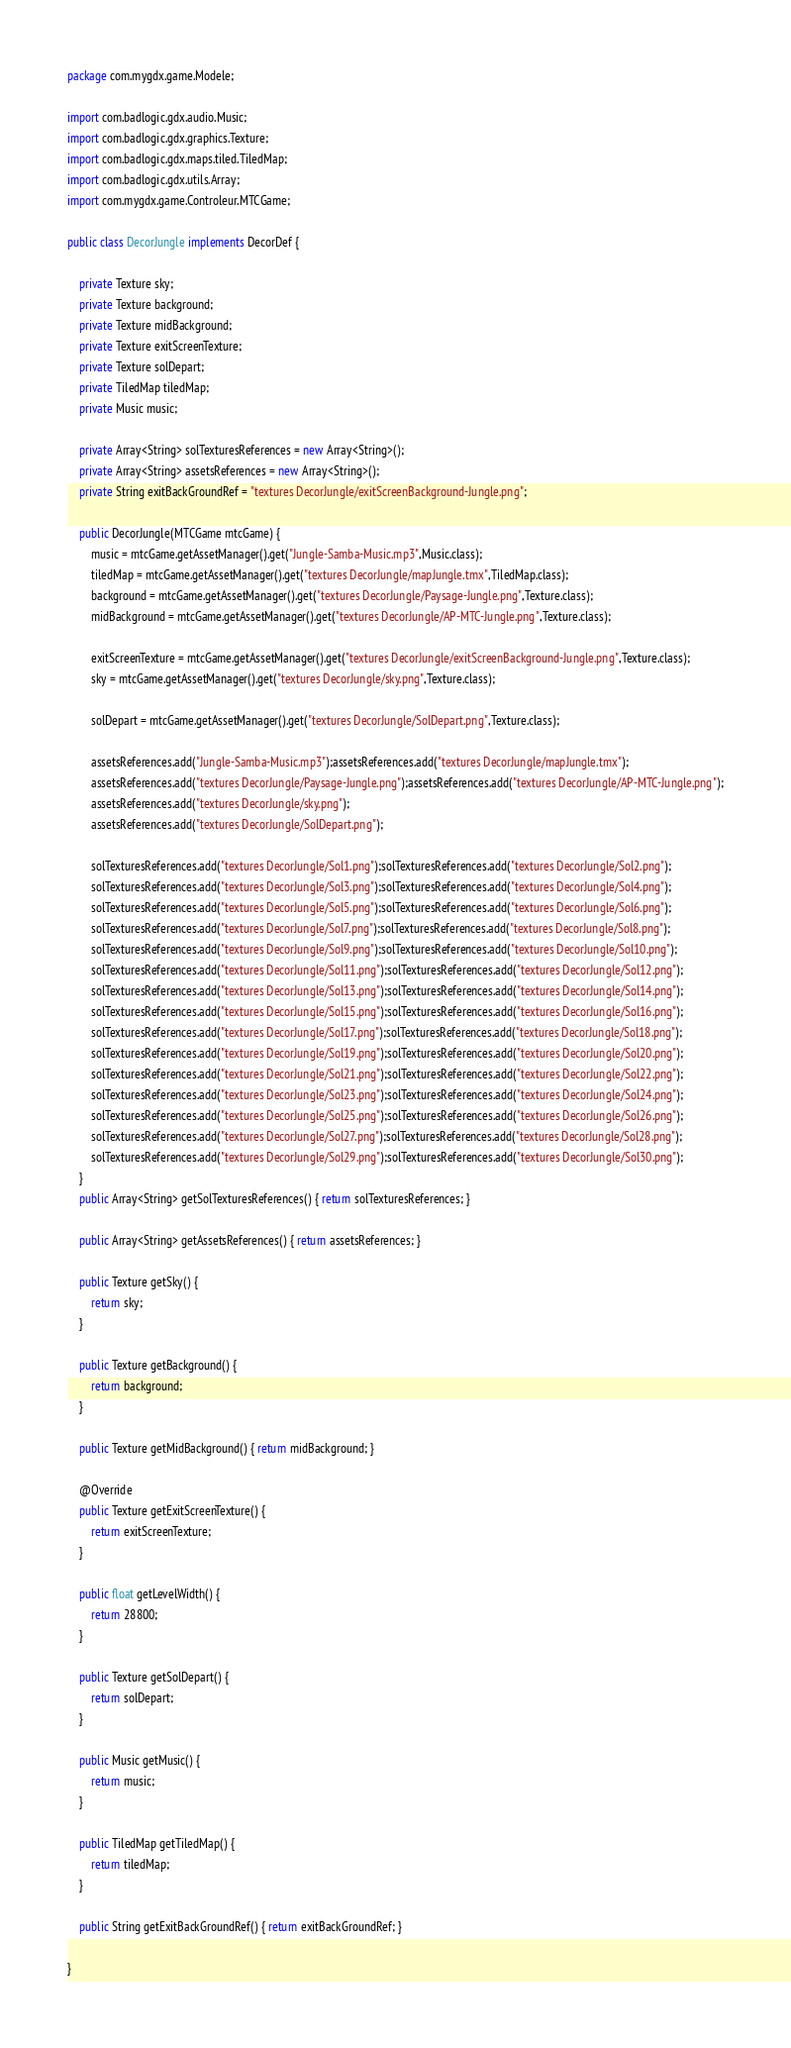Convert code to text. <code><loc_0><loc_0><loc_500><loc_500><_Java_>package com.mygdx.game.Modele;

import com.badlogic.gdx.audio.Music;
import com.badlogic.gdx.graphics.Texture;
import com.badlogic.gdx.maps.tiled.TiledMap;
import com.badlogic.gdx.utils.Array;
import com.mygdx.game.Controleur.MTCGame;

public class DecorJungle implements DecorDef {

    private Texture sky;
    private Texture background;
    private Texture midBackground;
    private Texture exitScreenTexture;
    private Texture solDepart;
    private TiledMap tiledMap;
    private Music music;

    private Array<String> solTexturesReferences = new Array<String>();
    private Array<String> assetsReferences = new Array<String>();
    private String exitBackGroundRef = "textures DecorJungle/exitScreenBackground-Jungle.png";

    public DecorJungle(MTCGame mtcGame) {
        music = mtcGame.getAssetManager().get("Jungle-Samba-Music.mp3",Music.class);
        tiledMap = mtcGame.getAssetManager().get("textures DecorJungle/mapJungle.tmx",TiledMap.class);
        background = mtcGame.getAssetManager().get("textures DecorJungle/Paysage-Jungle.png",Texture.class);
        midBackground = mtcGame.getAssetManager().get("textures DecorJungle/AP-MTC-Jungle.png",Texture.class);

        exitScreenTexture = mtcGame.getAssetManager().get("textures DecorJungle/exitScreenBackground-Jungle.png",Texture.class);
        sky = mtcGame.getAssetManager().get("textures DecorJungle/sky.png",Texture.class);

        solDepart = mtcGame.getAssetManager().get("textures DecorJungle/SolDepart.png",Texture.class);

        assetsReferences.add("Jungle-Samba-Music.mp3");assetsReferences.add("textures DecorJungle/mapJungle.tmx");
        assetsReferences.add("textures DecorJungle/Paysage-Jungle.png");assetsReferences.add("textures DecorJungle/AP-MTC-Jungle.png");
        assetsReferences.add("textures DecorJungle/sky.png");
        assetsReferences.add("textures DecorJungle/SolDepart.png");

        solTexturesReferences.add("textures DecorJungle/Sol1.png");solTexturesReferences.add("textures DecorJungle/Sol2.png");
        solTexturesReferences.add("textures DecorJungle/Sol3.png");solTexturesReferences.add("textures DecorJungle/Sol4.png");
        solTexturesReferences.add("textures DecorJungle/Sol5.png");solTexturesReferences.add("textures DecorJungle/Sol6.png");
        solTexturesReferences.add("textures DecorJungle/Sol7.png");solTexturesReferences.add("textures DecorJungle/Sol8.png");
        solTexturesReferences.add("textures DecorJungle/Sol9.png");solTexturesReferences.add("textures DecorJungle/Sol10.png");
        solTexturesReferences.add("textures DecorJungle/Sol11.png");solTexturesReferences.add("textures DecorJungle/Sol12.png");
        solTexturesReferences.add("textures DecorJungle/Sol13.png");solTexturesReferences.add("textures DecorJungle/Sol14.png");
        solTexturesReferences.add("textures DecorJungle/Sol15.png");solTexturesReferences.add("textures DecorJungle/Sol16.png");
        solTexturesReferences.add("textures DecorJungle/Sol17.png");solTexturesReferences.add("textures DecorJungle/Sol18.png");
        solTexturesReferences.add("textures DecorJungle/Sol19.png");solTexturesReferences.add("textures DecorJungle/Sol20.png");
        solTexturesReferences.add("textures DecorJungle/Sol21.png");solTexturesReferences.add("textures DecorJungle/Sol22.png");
        solTexturesReferences.add("textures DecorJungle/Sol23.png");solTexturesReferences.add("textures DecorJungle/Sol24.png");
        solTexturesReferences.add("textures DecorJungle/Sol25.png");solTexturesReferences.add("textures DecorJungle/Sol26.png");
        solTexturesReferences.add("textures DecorJungle/Sol27.png");solTexturesReferences.add("textures DecorJungle/Sol28.png");
        solTexturesReferences.add("textures DecorJungle/Sol29.png");solTexturesReferences.add("textures DecorJungle/Sol30.png");
    }
    public Array<String> getSolTexturesReferences() { return solTexturesReferences; }

    public Array<String> getAssetsReferences() { return assetsReferences; }

    public Texture getSky() {
        return sky;
    }

    public Texture getBackground() {
        return background;
    }

    public Texture getMidBackground() { return midBackground; }

    @Override
    public Texture getExitScreenTexture() {
        return exitScreenTexture;
    }

    public float getLevelWidth() {
        return 28800;
    }

    public Texture getSolDepart() {
        return solDepart;
    }

    public Music getMusic() {
        return music;
    }

    public TiledMap getTiledMap() {
        return tiledMap;
    }

    public String getExitBackGroundRef() { return exitBackGroundRef; }

}
</code> 